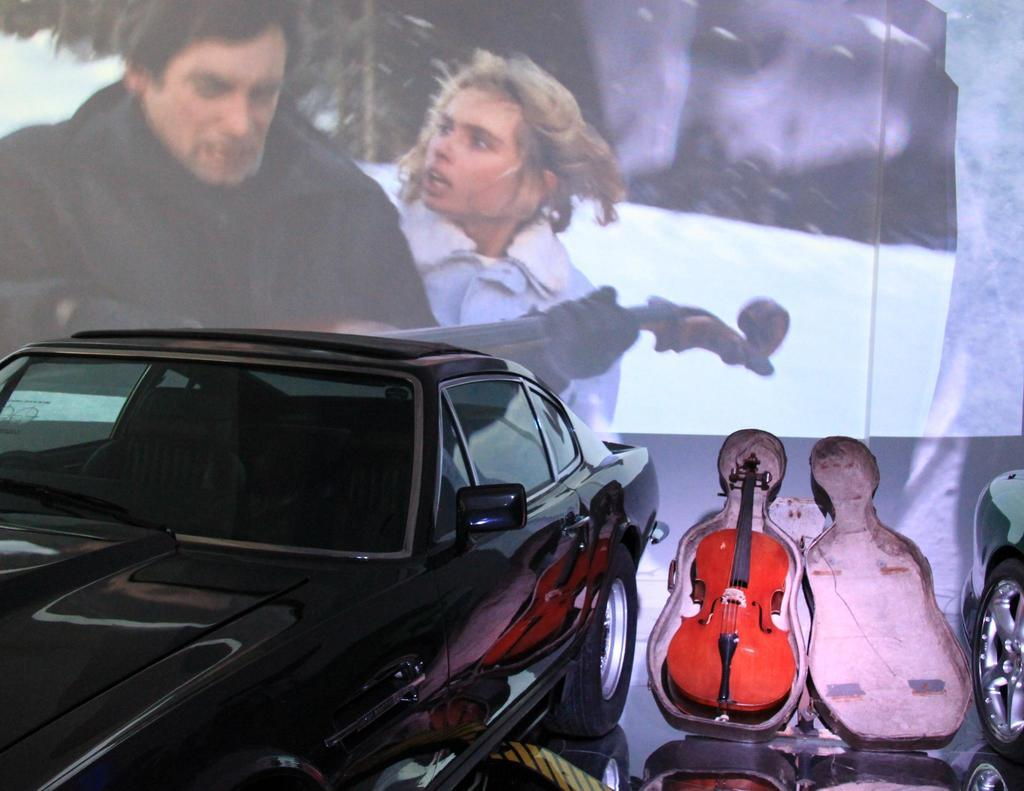What color is the car in the image? The car in the image is black. What musical instrument can be seen in the image? There is a red guitar in the image. What can be seen in the background of the image? There is a photo frame of a man and a woman in the background of the image. Is there a branch of a tree visible in the image? No, there is no branch of a tree visible in the image. Can you see any smoke coming from the car in the image? No, there is no smoke visible in the image. 